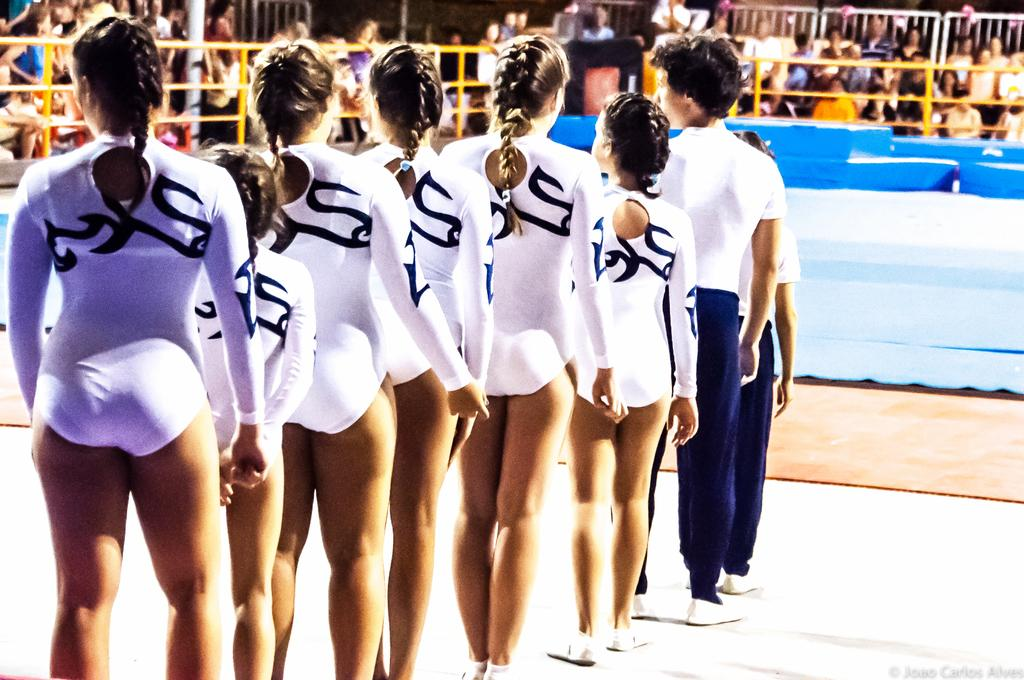What is the common feature among the people in the image? All the people are wearing white-colored dresses. What can be seen in the background of the image? There are yellow-colored railings in the background of the image. Can you describe the people in the background of the image? There are more people visible in the background of the image. What type of advertisement is being displayed on the railings in the image? There is no advertisement visible on the railings in the image; they are simply yellow-colored. Can you tell me what kind of pet is sitting next to the people in the image? There is no pet present in the image; it only features people wearing white-colored dresses and yellow-colored railings in the background. 